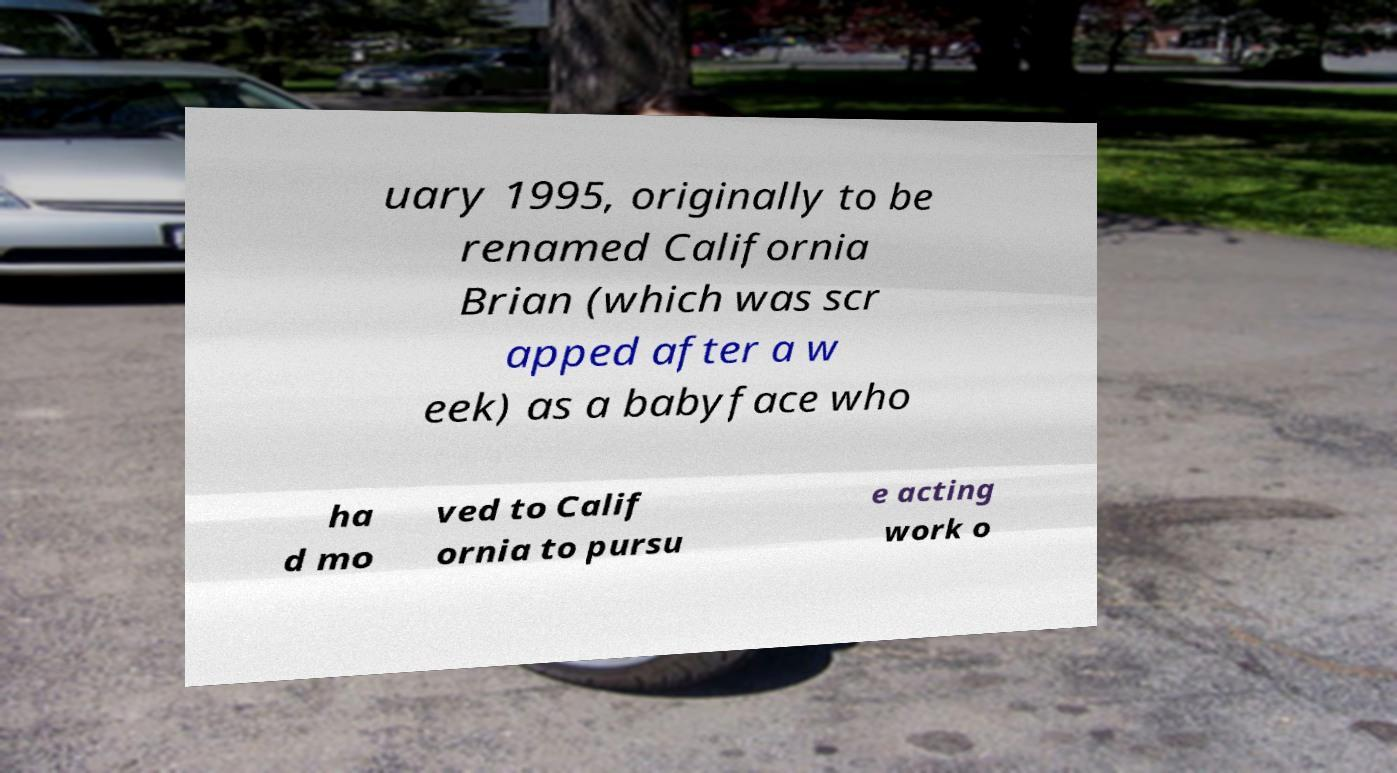I need the written content from this picture converted into text. Can you do that? uary 1995, originally to be renamed California Brian (which was scr apped after a w eek) as a babyface who ha d mo ved to Calif ornia to pursu e acting work o 